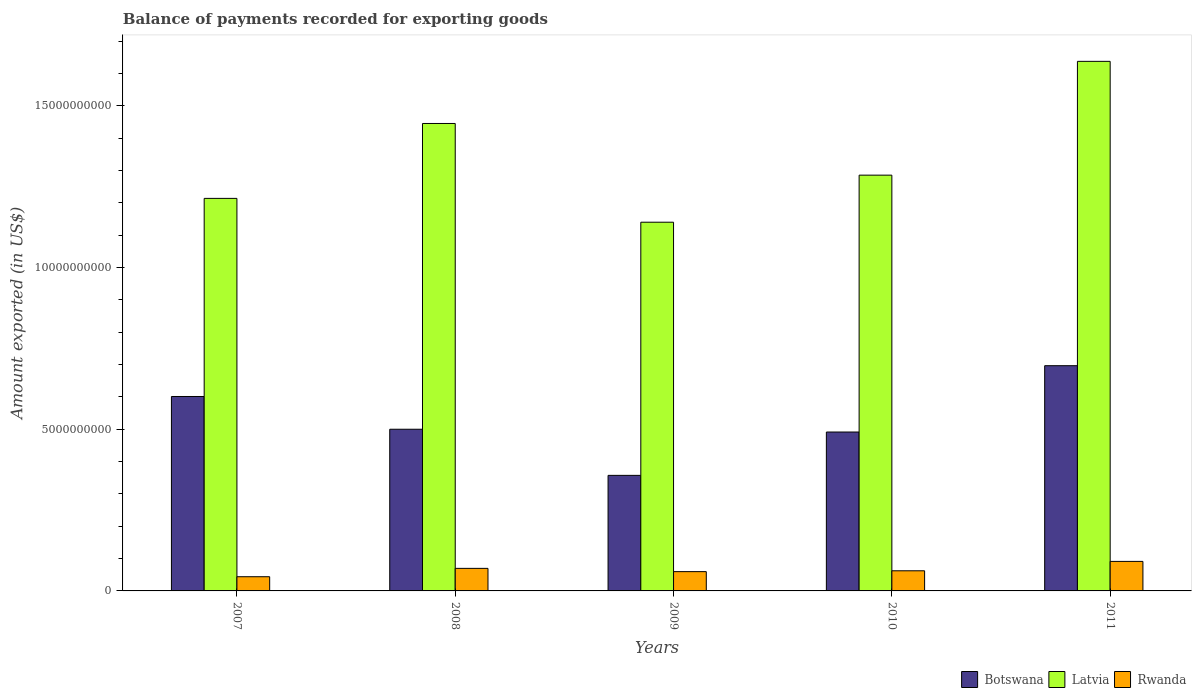How many different coloured bars are there?
Offer a very short reply. 3. How many bars are there on the 3rd tick from the left?
Give a very brief answer. 3. How many bars are there on the 2nd tick from the right?
Ensure brevity in your answer.  3. What is the label of the 3rd group of bars from the left?
Offer a terse response. 2009. What is the amount exported in Botswana in 2008?
Provide a short and direct response. 5.00e+09. Across all years, what is the maximum amount exported in Botswana?
Make the answer very short. 6.96e+09. Across all years, what is the minimum amount exported in Botswana?
Give a very brief answer. 3.57e+09. What is the total amount exported in Rwanda in the graph?
Make the answer very short. 3.27e+09. What is the difference between the amount exported in Rwanda in 2007 and that in 2009?
Make the answer very short. -1.58e+08. What is the difference between the amount exported in Botswana in 2011 and the amount exported in Latvia in 2008?
Offer a terse response. -7.49e+09. What is the average amount exported in Latvia per year?
Provide a short and direct response. 1.34e+1. In the year 2011, what is the difference between the amount exported in Rwanda and amount exported in Botswana?
Give a very brief answer. -6.05e+09. What is the ratio of the amount exported in Rwanda in 2009 to that in 2011?
Provide a succinct answer. 0.65. Is the amount exported in Rwanda in 2008 less than that in 2009?
Provide a succinct answer. No. What is the difference between the highest and the second highest amount exported in Botswana?
Your response must be concise. 9.52e+08. What is the difference between the highest and the lowest amount exported in Latvia?
Offer a terse response. 4.97e+09. Is the sum of the amount exported in Botswana in 2008 and 2009 greater than the maximum amount exported in Latvia across all years?
Offer a very short reply. No. What does the 1st bar from the left in 2011 represents?
Offer a terse response. Botswana. What does the 3rd bar from the right in 2008 represents?
Make the answer very short. Botswana. Is it the case that in every year, the sum of the amount exported in Botswana and amount exported in Rwanda is greater than the amount exported in Latvia?
Provide a short and direct response. No. Are all the bars in the graph horizontal?
Your answer should be compact. No. How many years are there in the graph?
Provide a succinct answer. 5. What is the difference between two consecutive major ticks on the Y-axis?
Give a very brief answer. 5.00e+09. Does the graph contain any zero values?
Keep it short and to the point. No. Does the graph contain grids?
Provide a succinct answer. No. How many legend labels are there?
Your answer should be compact. 3. What is the title of the graph?
Your answer should be compact. Balance of payments recorded for exporting goods. What is the label or title of the Y-axis?
Your answer should be compact. Amount exported (in US$). What is the Amount exported (in US$) of Botswana in 2007?
Offer a very short reply. 6.01e+09. What is the Amount exported (in US$) in Latvia in 2007?
Offer a very short reply. 1.21e+1. What is the Amount exported (in US$) of Rwanda in 2007?
Provide a short and direct response. 4.39e+08. What is the Amount exported (in US$) of Botswana in 2008?
Give a very brief answer. 5.00e+09. What is the Amount exported (in US$) in Latvia in 2008?
Offer a terse response. 1.45e+1. What is the Amount exported (in US$) of Rwanda in 2008?
Your answer should be compact. 6.97e+08. What is the Amount exported (in US$) of Botswana in 2009?
Offer a terse response. 3.57e+09. What is the Amount exported (in US$) in Latvia in 2009?
Provide a succinct answer. 1.14e+1. What is the Amount exported (in US$) of Rwanda in 2009?
Provide a short and direct response. 5.96e+08. What is the Amount exported (in US$) in Botswana in 2010?
Your answer should be compact. 4.91e+09. What is the Amount exported (in US$) of Latvia in 2010?
Make the answer very short. 1.29e+1. What is the Amount exported (in US$) of Rwanda in 2010?
Offer a very short reply. 6.23e+08. What is the Amount exported (in US$) of Botswana in 2011?
Offer a terse response. 6.96e+09. What is the Amount exported (in US$) of Latvia in 2011?
Make the answer very short. 1.64e+1. What is the Amount exported (in US$) of Rwanda in 2011?
Your response must be concise. 9.13e+08. Across all years, what is the maximum Amount exported (in US$) of Botswana?
Give a very brief answer. 6.96e+09. Across all years, what is the maximum Amount exported (in US$) of Latvia?
Your answer should be compact. 1.64e+1. Across all years, what is the maximum Amount exported (in US$) in Rwanda?
Provide a succinct answer. 9.13e+08. Across all years, what is the minimum Amount exported (in US$) of Botswana?
Offer a terse response. 3.57e+09. Across all years, what is the minimum Amount exported (in US$) in Latvia?
Ensure brevity in your answer.  1.14e+1. Across all years, what is the minimum Amount exported (in US$) in Rwanda?
Offer a terse response. 4.39e+08. What is the total Amount exported (in US$) of Botswana in the graph?
Give a very brief answer. 2.65e+1. What is the total Amount exported (in US$) in Latvia in the graph?
Keep it short and to the point. 6.72e+1. What is the total Amount exported (in US$) in Rwanda in the graph?
Ensure brevity in your answer.  3.27e+09. What is the difference between the Amount exported (in US$) of Botswana in 2007 and that in 2008?
Keep it short and to the point. 1.01e+09. What is the difference between the Amount exported (in US$) in Latvia in 2007 and that in 2008?
Your response must be concise. -2.32e+09. What is the difference between the Amount exported (in US$) of Rwanda in 2007 and that in 2008?
Provide a short and direct response. -2.59e+08. What is the difference between the Amount exported (in US$) of Botswana in 2007 and that in 2009?
Offer a terse response. 2.44e+09. What is the difference between the Amount exported (in US$) of Latvia in 2007 and that in 2009?
Keep it short and to the point. 7.37e+08. What is the difference between the Amount exported (in US$) in Rwanda in 2007 and that in 2009?
Your answer should be compact. -1.58e+08. What is the difference between the Amount exported (in US$) of Botswana in 2007 and that in 2010?
Give a very brief answer. 1.10e+09. What is the difference between the Amount exported (in US$) in Latvia in 2007 and that in 2010?
Provide a short and direct response. -7.18e+08. What is the difference between the Amount exported (in US$) of Rwanda in 2007 and that in 2010?
Ensure brevity in your answer.  -1.84e+08. What is the difference between the Amount exported (in US$) in Botswana in 2007 and that in 2011?
Your answer should be compact. -9.52e+08. What is the difference between the Amount exported (in US$) in Latvia in 2007 and that in 2011?
Make the answer very short. -4.24e+09. What is the difference between the Amount exported (in US$) in Rwanda in 2007 and that in 2011?
Offer a very short reply. -4.74e+08. What is the difference between the Amount exported (in US$) of Botswana in 2008 and that in 2009?
Your answer should be compact. 1.43e+09. What is the difference between the Amount exported (in US$) in Latvia in 2008 and that in 2009?
Make the answer very short. 3.05e+09. What is the difference between the Amount exported (in US$) of Rwanda in 2008 and that in 2009?
Provide a succinct answer. 1.01e+08. What is the difference between the Amount exported (in US$) in Botswana in 2008 and that in 2010?
Offer a terse response. 8.60e+07. What is the difference between the Amount exported (in US$) in Latvia in 2008 and that in 2010?
Ensure brevity in your answer.  1.60e+09. What is the difference between the Amount exported (in US$) of Rwanda in 2008 and that in 2010?
Ensure brevity in your answer.  7.49e+07. What is the difference between the Amount exported (in US$) in Botswana in 2008 and that in 2011?
Make the answer very short. -1.96e+09. What is the difference between the Amount exported (in US$) of Latvia in 2008 and that in 2011?
Offer a terse response. -1.92e+09. What is the difference between the Amount exported (in US$) in Rwanda in 2008 and that in 2011?
Keep it short and to the point. -2.15e+08. What is the difference between the Amount exported (in US$) of Botswana in 2009 and that in 2010?
Provide a short and direct response. -1.34e+09. What is the difference between the Amount exported (in US$) in Latvia in 2009 and that in 2010?
Offer a terse response. -1.45e+09. What is the difference between the Amount exported (in US$) in Rwanda in 2009 and that in 2010?
Your answer should be very brief. -2.61e+07. What is the difference between the Amount exported (in US$) in Botswana in 2009 and that in 2011?
Your answer should be compact. -3.39e+09. What is the difference between the Amount exported (in US$) of Latvia in 2009 and that in 2011?
Your answer should be very brief. -4.97e+09. What is the difference between the Amount exported (in US$) of Rwanda in 2009 and that in 2011?
Keep it short and to the point. -3.16e+08. What is the difference between the Amount exported (in US$) of Botswana in 2010 and that in 2011?
Provide a short and direct response. -2.05e+09. What is the difference between the Amount exported (in US$) in Latvia in 2010 and that in 2011?
Keep it short and to the point. -3.52e+09. What is the difference between the Amount exported (in US$) in Rwanda in 2010 and that in 2011?
Keep it short and to the point. -2.90e+08. What is the difference between the Amount exported (in US$) of Botswana in 2007 and the Amount exported (in US$) of Latvia in 2008?
Your answer should be very brief. -8.44e+09. What is the difference between the Amount exported (in US$) in Botswana in 2007 and the Amount exported (in US$) in Rwanda in 2008?
Provide a succinct answer. 5.31e+09. What is the difference between the Amount exported (in US$) in Latvia in 2007 and the Amount exported (in US$) in Rwanda in 2008?
Provide a succinct answer. 1.14e+1. What is the difference between the Amount exported (in US$) of Botswana in 2007 and the Amount exported (in US$) of Latvia in 2009?
Make the answer very short. -5.39e+09. What is the difference between the Amount exported (in US$) in Botswana in 2007 and the Amount exported (in US$) in Rwanda in 2009?
Provide a succinct answer. 5.42e+09. What is the difference between the Amount exported (in US$) in Latvia in 2007 and the Amount exported (in US$) in Rwanda in 2009?
Provide a succinct answer. 1.15e+1. What is the difference between the Amount exported (in US$) of Botswana in 2007 and the Amount exported (in US$) of Latvia in 2010?
Ensure brevity in your answer.  -6.84e+09. What is the difference between the Amount exported (in US$) of Botswana in 2007 and the Amount exported (in US$) of Rwanda in 2010?
Ensure brevity in your answer.  5.39e+09. What is the difference between the Amount exported (in US$) in Latvia in 2007 and the Amount exported (in US$) in Rwanda in 2010?
Provide a short and direct response. 1.15e+1. What is the difference between the Amount exported (in US$) of Botswana in 2007 and the Amount exported (in US$) of Latvia in 2011?
Offer a terse response. -1.04e+1. What is the difference between the Amount exported (in US$) of Botswana in 2007 and the Amount exported (in US$) of Rwanda in 2011?
Provide a short and direct response. 5.10e+09. What is the difference between the Amount exported (in US$) of Latvia in 2007 and the Amount exported (in US$) of Rwanda in 2011?
Provide a short and direct response. 1.12e+1. What is the difference between the Amount exported (in US$) in Botswana in 2008 and the Amount exported (in US$) in Latvia in 2009?
Give a very brief answer. -6.40e+09. What is the difference between the Amount exported (in US$) in Botswana in 2008 and the Amount exported (in US$) in Rwanda in 2009?
Keep it short and to the point. 4.40e+09. What is the difference between the Amount exported (in US$) in Latvia in 2008 and the Amount exported (in US$) in Rwanda in 2009?
Make the answer very short. 1.39e+1. What is the difference between the Amount exported (in US$) of Botswana in 2008 and the Amount exported (in US$) of Latvia in 2010?
Your answer should be compact. -7.86e+09. What is the difference between the Amount exported (in US$) in Botswana in 2008 and the Amount exported (in US$) in Rwanda in 2010?
Provide a succinct answer. 4.38e+09. What is the difference between the Amount exported (in US$) of Latvia in 2008 and the Amount exported (in US$) of Rwanda in 2010?
Ensure brevity in your answer.  1.38e+1. What is the difference between the Amount exported (in US$) in Botswana in 2008 and the Amount exported (in US$) in Latvia in 2011?
Provide a succinct answer. -1.14e+1. What is the difference between the Amount exported (in US$) in Botswana in 2008 and the Amount exported (in US$) in Rwanda in 2011?
Your response must be concise. 4.09e+09. What is the difference between the Amount exported (in US$) of Latvia in 2008 and the Amount exported (in US$) of Rwanda in 2011?
Your answer should be very brief. 1.35e+1. What is the difference between the Amount exported (in US$) in Botswana in 2009 and the Amount exported (in US$) in Latvia in 2010?
Your answer should be compact. -9.28e+09. What is the difference between the Amount exported (in US$) in Botswana in 2009 and the Amount exported (in US$) in Rwanda in 2010?
Your response must be concise. 2.95e+09. What is the difference between the Amount exported (in US$) of Latvia in 2009 and the Amount exported (in US$) of Rwanda in 2010?
Ensure brevity in your answer.  1.08e+1. What is the difference between the Amount exported (in US$) in Botswana in 2009 and the Amount exported (in US$) in Latvia in 2011?
Offer a very short reply. -1.28e+1. What is the difference between the Amount exported (in US$) in Botswana in 2009 and the Amount exported (in US$) in Rwanda in 2011?
Ensure brevity in your answer.  2.66e+09. What is the difference between the Amount exported (in US$) in Latvia in 2009 and the Amount exported (in US$) in Rwanda in 2011?
Your response must be concise. 1.05e+1. What is the difference between the Amount exported (in US$) of Botswana in 2010 and the Amount exported (in US$) of Latvia in 2011?
Your response must be concise. -1.15e+1. What is the difference between the Amount exported (in US$) of Botswana in 2010 and the Amount exported (in US$) of Rwanda in 2011?
Provide a short and direct response. 4.00e+09. What is the difference between the Amount exported (in US$) of Latvia in 2010 and the Amount exported (in US$) of Rwanda in 2011?
Give a very brief answer. 1.19e+1. What is the average Amount exported (in US$) in Botswana per year?
Your answer should be very brief. 5.29e+09. What is the average Amount exported (in US$) of Latvia per year?
Offer a terse response. 1.34e+1. What is the average Amount exported (in US$) in Rwanda per year?
Your answer should be compact. 6.54e+08. In the year 2007, what is the difference between the Amount exported (in US$) of Botswana and Amount exported (in US$) of Latvia?
Your response must be concise. -6.13e+09. In the year 2007, what is the difference between the Amount exported (in US$) of Botswana and Amount exported (in US$) of Rwanda?
Offer a terse response. 5.57e+09. In the year 2007, what is the difference between the Amount exported (in US$) in Latvia and Amount exported (in US$) in Rwanda?
Ensure brevity in your answer.  1.17e+1. In the year 2008, what is the difference between the Amount exported (in US$) of Botswana and Amount exported (in US$) of Latvia?
Make the answer very short. -9.45e+09. In the year 2008, what is the difference between the Amount exported (in US$) of Botswana and Amount exported (in US$) of Rwanda?
Your response must be concise. 4.30e+09. In the year 2008, what is the difference between the Amount exported (in US$) in Latvia and Amount exported (in US$) in Rwanda?
Keep it short and to the point. 1.38e+1. In the year 2009, what is the difference between the Amount exported (in US$) in Botswana and Amount exported (in US$) in Latvia?
Your response must be concise. -7.83e+09. In the year 2009, what is the difference between the Amount exported (in US$) of Botswana and Amount exported (in US$) of Rwanda?
Ensure brevity in your answer.  2.98e+09. In the year 2009, what is the difference between the Amount exported (in US$) of Latvia and Amount exported (in US$) of Rwanda?
Give a very brief answer. 1.08e+1. In the year 2010, what is the difference between the Amount exported (in US$) in Botswana and Amount exported (in US$) in Latvia?
Keep it short and to the point. -7.94e+09. In the year 2010, what is the difference between the Amount exported (in US$) of Botswana and Amount exported (in US$) of Rwanda?
Offer a very short reply. 4.29e+09. In the year 2010, what is the difference between the Amount exported (in US$) of Latvia and Amount exported (in US$) of Rwanda?
Provide a short and direct response. 1.22e+1. In the year 2011, what is the difference between the Amount exported (in US$) in Botswana and Amount exported (in US$) in Latvia?
Provide a short and direct response. -9.41e+09. In the year 2011, what is the difference between the Amount exported (in US$) of Botswana and Amount exported (in US$) of Rwanda?
Your answer should be compact. 6.05e+09. In the year 2011, what is the difference between the Amount exported (in US$) of Latvia and Amount exported (in US$) of Rwanda?
Offer a very short reply. 1.55e+1. What is the ratio of the Amount exported (in US$) of Botswana in 2007 to that in 2008?
Provide a short and direct response. 1.2. What is the ratio of the Amount exported (in US$) of Latvia in 2007 to that in 2008?
Provide a short and direct response. 0.84. What is the ratio of the Amount exported (in US$) in Rwanda in 2007 to that in 2008?
Make the answer very short. 0.63. What is the ratio of the Amount exported (in US$) in Botswana in 2007 to that in 2009?
Ensure brevity in your answer.  1.68. What is the ratio of the Amount exported (in US$) in Latvia in 2007 to that in 2009?
Make the answer very short. 1.06. What is the ratio of the Amount exported (in US$) of Rwanda in 2007 to that in 2009?
Provide a succinct answer. 0.74. What is the ratio of the Amount exported (in US$) in Botswana in 2007 to that in 2010?
Offer a terse response. 1.22. What is the ratio of the Amount exported (in US$) of Latvia in 2007 to that in 2010?
Provide a short and direct response. 0.94. What is the ratio of the Amount exported (in US$) of Rwanda in 2007 to that in 2010?
Offer a terse response. 0.7. What is the ratio of the Amount exported (in US$) of Botswana in 2007 to that in 2011?
Give a very brief answer. 0.86. What is the ratio of the Amount exported (in US$) of Latvia in 2007 to that in 2011?
Your response must be concise. 0.74. What is the ratio of the Amount exported (in US$) in Rwanda in 2007 to that in 2011?
Provide a short and direct response. 0.48. What is the ratio of the Amount exported (in US$) in Botswana in 2008 to that in 2009?
Your answer should be very brief. 1.4. What is the ratio of the Amount exported (in US$) in Latvia in 2008 to that in 2009?
Ensure brevity in your answer.  1.27. What is the ratio of the Amount exported (in US$) of Rwanda in 2008 to that in 2009?
Your answer should be very brief. 1.17. What is the ratio of the Amount exported (in US$) in Botswana in 2008 to that in 2010?
Provide a short and direct response. 1.02. What is the ratio of the Amount exported (in US$) of Latvia in 2008 to that in 2010?
Your response must be concise. 1.12. What is the ratio of the Amount exported (in US$) of Rwanda in 2008 to that in 2010?
Offer a very short reply. 1.12. What is the ratio of the Amount exported (in US$) in Botswana in 2008 to that in 2011?
Your answer should be compact. 0.72. What is the ratio of the Amount exported (in US$) of Latvia in 2008 to that in 2011?
Keep it short and to the point. 0.88. What is the ratio of the Amount exported (in US$) in Rwanda in 2008 to that in 2011?
Ensure brevity in your answer.  0.76. What is the ratio of the Amount exported (in US$) of Botswana in 2009 to that in 2010?
Provide a succinct answer. 0.73. What is the ratio of the Amount exported (in US$) of Latvia in 2009 to that in 2010?
Your answer should be very brief. 0.89. What is the ratio of the Amount exported (in US$) in Rwanda in 2009 to that in 2010?
Offer a very short reply. 0.96. What is the ratio of the Amount exported (in US$) in Botswana in 2009 to that in 2011?
Your answer should be very brief. 0.51. What is the ratio of the Amount exported (in US$) of Latvia in 2009 to that in 2011?
Your answer should be compact. 0.7. What is the ratio of the Amount exported (in US$) in Rwanda in 2009 to that in 2011?
Provide a short and direct response. 0.65. What is the ratio of the Amount exported (in US$) of Botswana in 2010 to that in 2011?
Your answer should be compact. 0.71. What is the ratio of the Amount exported (in US$) of Latvia in 2010 to that in 2011?
Provide a succinct answer. 0.79. What is the ratio of the Amount exported (in US$) in Rwanda in 2010 to that in 2011?
Provide a succinct answer. 0.68. What is the difference between the highest and the second highest Amount exported (in US$) of Botswana?
Your response must be concise. 9.52e+08. What is the difference between the highest and the second highest Amount exported (in US$) of Latvia?
Your answer should be compact. 1.92e+09. What is the difference between the highest and the second highest Amount exported (in US$) of Rwanda?
Offer a very short reply. 2.15e+08. What is the difference between the highest and the lowest Amount exported (in US$) in Botswana?
Provide a succinct answer. 3.39e+09. What is the difference between the highest and the lowest Amount exported (in US$) of Latvia?
Keep it short and to the point. 4.97e+09. What is the difference between the highest and the lowest Amount exported (in US$) of Rwanda?
Make the answer very short. 4.74e+08. 